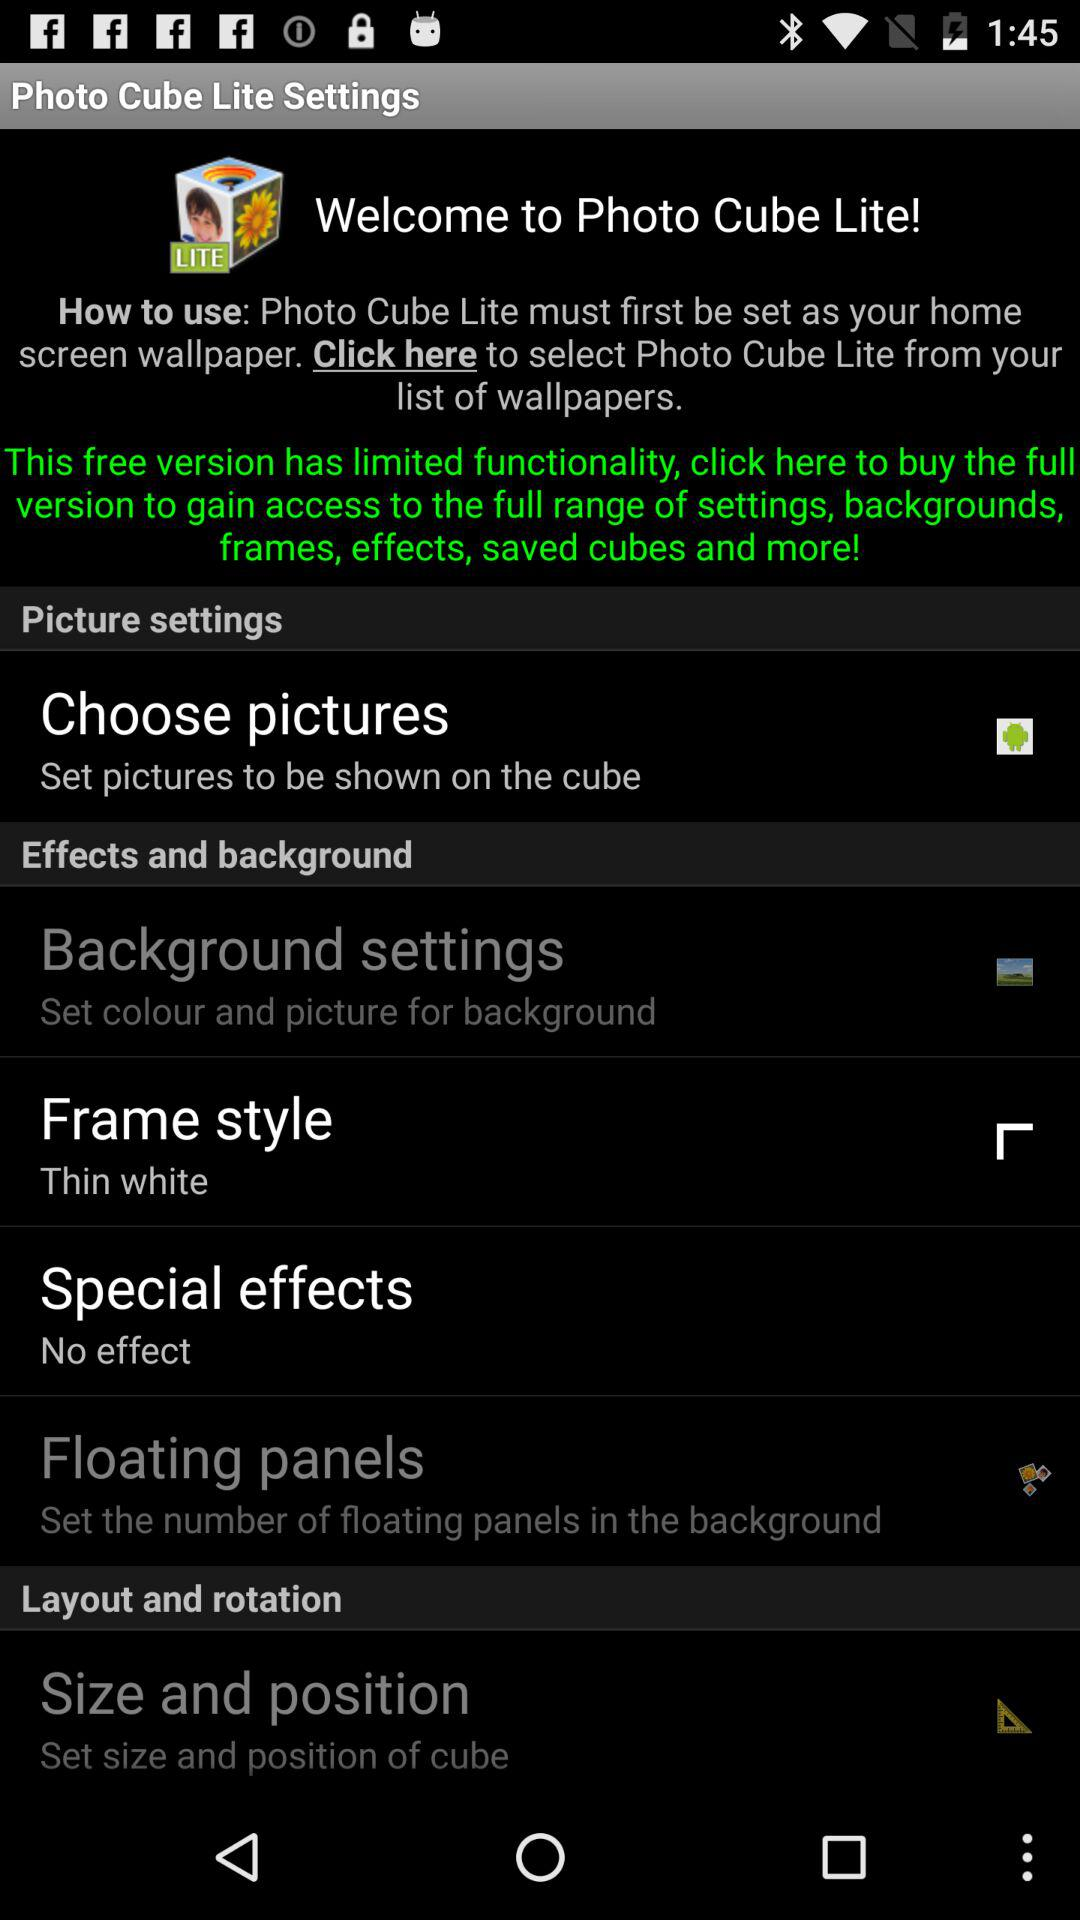What's the status for "Choose pictures"? The status is "on". 